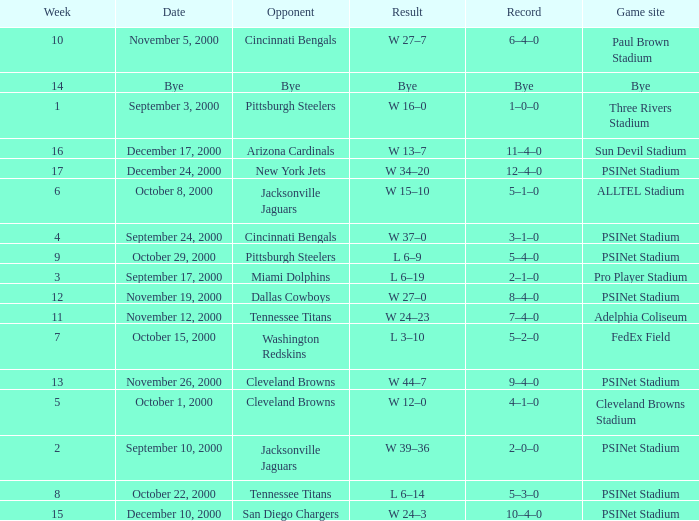What's the record after week 12 with a game site of bye? Bye. 